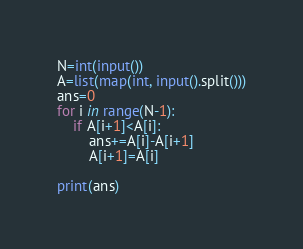Convert code to text. <code><loc_0><loc_0><loc_500><loc_500><_Python_>N=int(input())
A=list(map(int, input().split()))
ans=0
for i in range(N-1):
	if A[i+1]<A[i]:
		ans+=A[i]-A[i+1]
		A[i+1]=A[i]

print(ans)</code> 